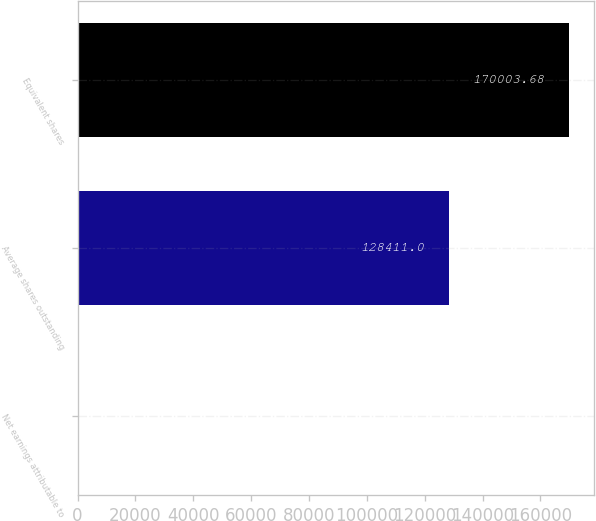<chart> <loc_0><loc_0><loc_500><loc_500><bar_chart><fcel>Net earnings attributable to<fcel>Average shares outstanding<fcel>Equivalent shares<nl><fcel>3.24<fcel>128411<fcel>170004<nl></chart> 